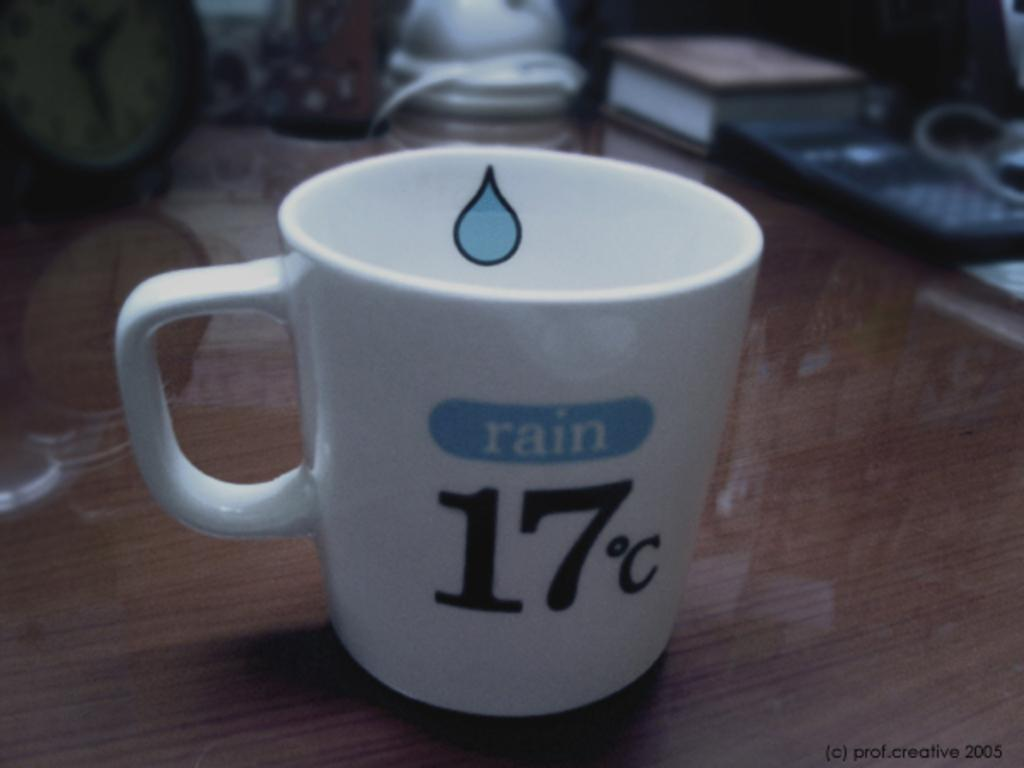Provide a one-sentence caption for the provided image. A white teacup that has a blue raindrop on the inside, the word rain in blue and 17 degrees c on the front logo. 